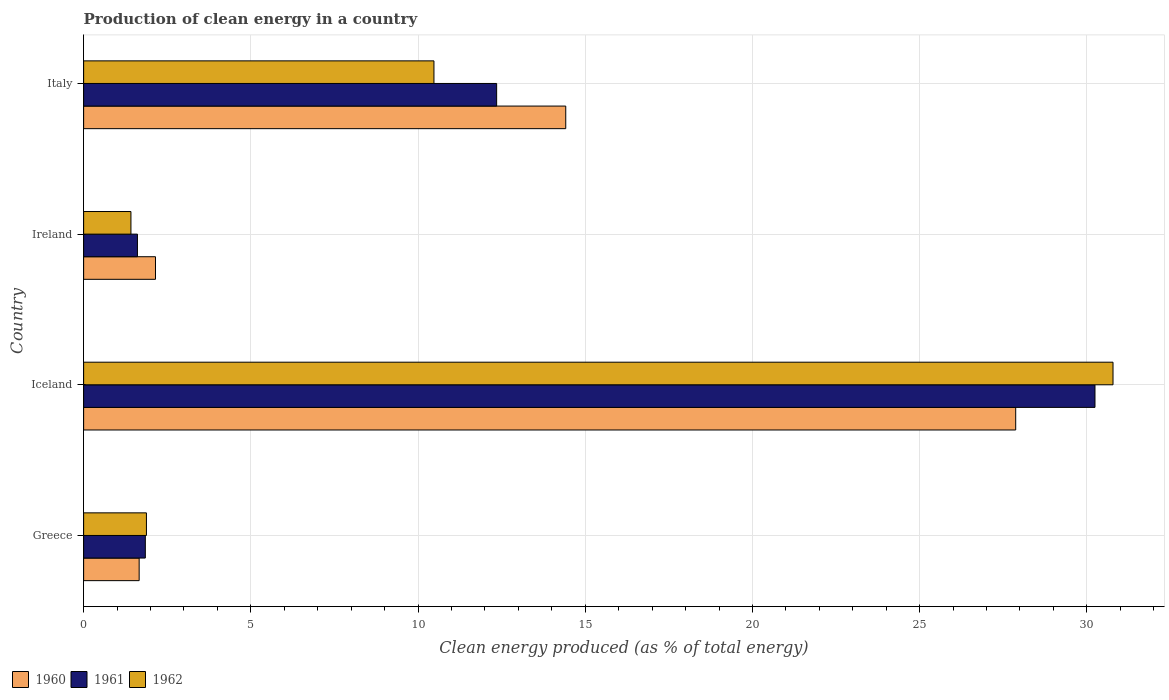How many different coloured bars are there?
Keep it short and to the point. 3. How many groups of bars are there?
Provide a succinct answer. 4. Are the number of bars on each tick of the Y-axis equal?
Ensure brevity in your answer.  Yes. How many bars are there on the 2nd tick from the top?
Offer a very short reply. 3. What is the label of the 1st group of bars from the top?
Your response must be concise. Italy. What is the percentage of clean energy produced in 1960 in Italy?
Keep it short and to the point. 14.42. Across all countries, what is the maximum percentage of clean energy produced in 1961?
Give a very brief answer. 30.24. Across all countries, what is the minimum percentage of clean energy produced in 1961?
Your answer should be compact. 1.61. In which country was the percentage of clean energy produced in 1960 maximum?
Keep it short and to the point. Iceland. In which country was the percentage of clean energy produced in 1962 minimum?
Your answer should be compact. Ireland. What is the total percentage of clean energy produced in 1960 in the graph?
Offer a very short reply. 46.1. What is the difference between the percentage of clean energy produced in 1960 in Greece and that in Italy?
Offer a very short reply. -12.76. What is the difference between the percentage of clean energy produced in 1962 in Italy and the percentage of clean energy produced in 1960 in Iceland?
Provide a succinct answer. -17.4. What is the average percentage of clean energy produced in 1960 per country?
Provide a succinct answer. 11.52. What is the difference between the percentage of clean energy produced in 1961 and percentage of clean energy produced in 1962 in Italy?
Provide a succinct answer. 1.87. What is the ratio of the percentage of clean energy produced in 1962 in Greece to that in Iceland?
Your response must be concise. 0.06. What is the difference between the highest and the second highest percentage of clean energy produced in 1962?
Provide a succinct answer. 20.31. What is the difference between the highest and the lowest percentage of clean energy produced in 1962?
Your response must be concise. 29.37. Is the sum of the percentage of clean energy produced in 1962 in Iceland and Italy greater than the maximum percentage of clean energy produced in 1960 across all countries?
Offer a terse response. Yes. What does the 3rd bar from the top in Greece represents?
Give a very brief answer. 1960. What does the 1st bar from the bottom in Iceland represents?
Make the answer very short. 1960. Is it the case that in every country, the sum of the percentage of clean energy produced in 1960 and percentage of clean energy produced in 1961 is greater than the percentage of clean energy produced in 1962?
Make the answer very short. Yes. How many bars are there?
Your answer should be compact. 12. What is the difference between two consecutive major ticks on the X-axis?
Make the answer very short. 5. Are the values on the major ticks of X-axis written in scientific E-notation?
Your answer should be compact. No. Does the graph contain any zero values?
Keep it short and to the point. No. How many legend labels are there?
Your answer should be very brief. 3. What is the title of the graph?
Provide a short and direct response. Production of clean energy in a country. What is the label or title of the X-axis?
Your response must be concise. Clean energy produced (as % of total energy). What is the label or title of the Y-axis?
Give a very brief answer. Country. What is the Clean energy produced (as % of total energy) of 1960 in Greece?
Ensure brevity in your answer.  1.66. What is the Clean energy produced (as % of total energy) in 1961 in Greece?
Keep it short and to the point. 1.84. What is the Clean energy produced (as % of total energy) of 1962 in Greece?
Keep it short and to the point. 1.88. What is the Clean energy produced (as % of total energy) in 1960 in Iceland?
Your response must be concise. 27.87. What is the Clean energy produced (as % of total energy) in 1961 in Iceland?
Offer a terse response. 30.24. What is the Clean energy produced (as % of total energy) in 1962 in Iceland?
Your answer should be compact. 30.78. What is the Clean energy produced (as % of total energy) in 1960 in Ireland?
Your answer should be compact. 2.15. What is the Clean energy produced (as % of total energy) of 1961 in Ireland?
Your response must be concise. 1.61. What is the Clean energy produced (as % of total energy) of 1962 in Ireland?
Give a very brief answer. 1.41. What is the Clean energy produced (as % of total energy) of 1960 in Italy?
Provide a short and direct response. 14.42. What is the Clean energy produced (as % of total energy) in 1961 in Italy?
Offer a very short reply. 12.35. What is the Clean energy produced (as % of total energy) of 1962 in Italy?
Ensure brevity in your answer.  10.48. Across all countries, what is the maximum Clean energy produced (as % of total energy) in 1960?
Your answer should be very brief. 27.87. Across all countries, what is the maximum Clean energy produced (as % of total energy) of 1961?
Make the answer very short. 30.24. Across all countries, what is the maximum Clean energy produced (as % of total energy) in 1962?
Provide a short and direct response. 30.78. Across all countries, what is the minimum Clean energy produced (as % of total energy) of 1960?
Your answer should be compact. 1.66. Across all countries, what is the minimum Clean energy produced (as % of total energy) of 1961?
Ensure brevity in your answer.  1.61. Across all countries, what is the minimum Clean energy produced (as % of total energy) of 1962?
Offer a terse response. 1.41. What is the total Clean energy produced (as % of total energy) of 1960 in the graph?
Ensure brevity in your answer.  46.1. What is the total Clean energy produced (as % of total energy) in 1961 in the graph?
Offer a very short reply. 46.05. What is the total Clean energy produced (as % of total energy) in 1962 in the graph?
Provide a short and direct response. 44.55. What is the difference between the Clean energy produced (as % of total energy) of 1960 in Greece and that in Iceland?
Keep it short and to the point. -26.21. What is the difference between the Clean energy produced (as % of total energy) in 1961 in Greece and that in Iceland?
Make the answer very short. -28.4. What is the difference between the Clean energy produced (as % of total energy) of 1962 in Greece and that in Iceland?
Make the answer very short. -28.9. What is the difference between the Clean energy produced (as % of total energy) in 1960 in Greece and that in Ireland?
Provide a succinct answer. -0.49. What is the difference between the Clean energy produced (as % of total energy) of 1961 in Greece and that in Ireland?
Offer a terse response. 0.24. What is the difference between the Clean energy produced (as % of total energy) of 1962 in Greece and that in Ireland?
Make the answer very short. 0.46. What is the difference between the Clean energy produced (as % of total energy) in 1960 in Greece and that in Italy?
Your answer should be very brief. -12.76. What is the difference between the Clean energy produced (as % of total energy) of 1961 in Greece and that in Italy?
Keep it short and to the point. -10.51. What is the difference between the Clean energy produced (as % of total energy) of 1962 in Greece and that in Italy?
Ensure brevity in your answer.  -8.6. What is the difference between the Clean energy produced (as % of total energy) of 1960 in Iceland and that in Ireland?
Your answer should be compact. 25.72. What is the difference between the Clean energy produced (as % of total energy) in 1961 in Iceland and that in Ireland?
Offer a very short reply. 28.63. What is the difference between the Clean energy produced (as % of total energy) of 1962 in Iceland and that in Ireland?
Offer a very short reply. 29.37. What is the difference between the Clean energy produced (as % of total energy) of 1960 in Iceland and that in Italy?
Offer a terse response. 13.46. What is the difference between the Clean energy produced (as % of total energy) of 1961 in Iceland and that in Italy?
Your answer should be very brief. 17.89. What is the difference between the Clean energy produced (as % of total energy) in 1962 in Iceland and that in Italy?
Ensure brevity in your answer.  20.31. What is the difference between the Clean energy produced (as % of total energy) in 1960 in Ireland and that in Italy?
Offer a terse response. -12.27. What is the difference between the Clean energy produced (as % of total energy) in 1961 in Ireland and that in Italy?
Ensure brevity in your answer.  -10.74. What is the difference between the Clean energy produced (as % of total energy) of 1962 in Ireland and that in Italy?
Give a very brief answer. -9.06. What is the difference between the Clean energy produced (as % of total energy) in 1960 in Greece and the Clean energy produced (as % of total energy) in 1961 in Iceland?
Ensure brevity in your answer.  -28.58. What is the difference between the Clean energy produced (as % of total energy) of 1960 in Greece and the Clean energy produced (as % of total energy) of 1962 in Iceland?
Ensure brevity in your answer.  -29.12. What is the difference between the Clean energy produced (as % of total energy) of 1961 in Greece and the Clean energy produced (as % of total energy) of 1962 in Iceland?
Ensure brevity in your answer.  -28.94. What is the difference between the Clean energy produced (as % of total energy) in 1960 in Greece and the Clean energy produced (as % of total energy) in 1961 in Ireland?
Ensure brevity in your answer.  0.05. What is the difference between the Clean energy produced (as % of total energy) in 1960 in Greece and the Clean energy produced (as % of total energy) in 1962 in Ireland?
Provide a short and direct response. 0.25. What is the difference between the Clean energy produced (as % of total energy) in 1961 in Greece and the Clean energy produced (as % of total energy) in 1962 in Ireland?
Provide a short and direct response. 0.43. What is the difference between the Clean energy produced (as % of total energy) of 1960 in Greece and the Clean energy produced (as % of total energy) of 1961 in Italy?
Offer a very short reply. -10.69. What is the difference between the Clean energy produced (as % of total energy) of 1960 in Greece and the Clean energy produced (as % of total energy) of 1962 in Italy?
Ensure brevity in your answer.  -8.82. What is the difference between the Clean energy produced (as % of total energy) in 1961 in Greece and the Clean energy produced (as % of total energy) in 1962 in Italy?
Your answer should be very brief. -8.63. What is the difference between the Clean energy produced (as % of total energy) of 1960 in Iceland and the Clean energy produced (as % of total energy) of 1961 in Ireland?
Keep it short and to the point. 26.26. What is the difference between the Clean energy produced (as % of total energy) in 1960 in Iceland and the Clean energy produced (as % of total energy) in 1962 in Ireland?
Provide a succinct answer. 26.46. What is the difference between the Clean energy produced (as % of total energy) of 1961 in Iceland and the Clean energy produced (as % of total energy) of 1962 in Ireland?
Make the answer very short. 28.83. What is the difference between the Clean energy produced (as % of total energy) in 1960 in Iceland and the Clean energy produced (as % of total energy) in 1961 in Italy?
Your answer should be very brief. 15.52. What is the difference between the Clean energy produced (as % of total energy) of 1960 in Iceland and the Clean energy produced (as % of total energy) of 1962 in Italy?
Your answer should be compact. 17.4. What is the difference between the Clean energy produced (as % of total energy) in 1961 in Iceland and the Clean energy produced (as % of total energy) in 1962 in Italy?
Make the answer very short. 19.77. What is the difference between the Clean energy produced (as % of total energy) in 1960 in Ireland and the Clean energy produced (as % of total energy) in 1961 in Italy?
Offer a terse response. -10.2. What is the difference between the Clean energy produced (as % of total energy) in 1960 in Ireland and the Clean energy produced (as % of total energy) in 1962 in Italy?
Make the answer very short. -8.33. What is the difference between the Clean energy produced (as % of total energy) of 1961 in Ireland and the Clean energy produced (as % of total energy) of 1962 in Italy?
Keep it short and to the point. -8.87. What is the average Clean energy produced (as % of total energy) in 1960 per country?
Give a very brief answer. 11.52. What is the average Clean energy produced (as % of total energy) in 1961 per country?
Offer a terse response. 11.51. What is the average Clean energy produced (as % of total energy) in 1962 per country?
Offer a terse response. 11.14. What is the difference between the Clean energy produced (as % of total energy) in 1960 and Clean energy produced (as % of total energy) in 1961 in Greece?
Ensure brevity in your answer.  -0.18. What is the difference between the Clean energy produced (as % of total energy) of 1960 and Clean energy produced (as % of total energy) of 1962 in Greece?
Provide a short and direct response. -0.22. What is the difference between the Clean energy produced (as % of total energy) of 1961 and Clean energy produced (as % of total energy) of 1962 in Greece?
Your response must be concise. -0.03. What is the difference between the Clean energy produced (as % of total energy) in 1960 and Clean energy produced (as % of total energy) in 1961 in Iceland?
Your answer should be compact. -2.37. What is the difference between the Clean energy produced (as % of total energy) of 1960 and Clean energy produced (as % of total energy) of 1962 in Iceland?
Your response must be concise. -2.91. What is the difference between the Clean energy produced (as % of total energy) of 1961 and Clean energy produced (as % of total energy) of 1962 in Iceland?
Offer a very short reply. -0.54. What is the difference between the Clean energy produced (as % of total energy) in 1960 and Clean energy produced (as % of total energy) in 1961 in Ireland?
Keep it short and to the point. 0.54. What is the difference between the Clean energy produced (as % of total energy) of 1960 and Clean energy produced (as % of total energy) of 1962 in Ireland?
Your answer should be very brief. 0.73. What is the difference between the Clean energy produced (as % of total energy) of 1961 and Clean energy produced (as % of total energy) of 1962 in Ireland?
Give a very brief answer. 0.19. What is the difference between the Clean energy produced (as % of total energy) of 1960 and Clean energy produced (as % of total energy) of 1961 in Italy?
Offer a terse response. 2.07. What is the difference between the Clean energy produced (as % of total energy) in 1960 and Clean energy produced (as % of total energy) in 1962 in Italy?
Offer a terse response. 3.94. What is the difference between the Clean energy produced (as % of total energy) of 1961 and Clean energy produced (as % of total energy) of 1962 in Italy?
Give a very brief answer. 1.87. What is the ratio of the Clean energy produced (as % of total energy) in 1960 in Greece to that in Iceland?
Your response must be concise. 0.06. What is the ratio of the Clean energy produced (as % of total energy) of 1961 in Greece to that in Iceland?
Your answer should be very brief. 0.06. What is the ratio of the Clean energy produced (as % of total energy) of 1962 in Greece to that in Iceland?
Offer a very short reply. 0.06. What is the ratio of the Clean energy produced (as % of total energy) in 1960 in Greece to that in Ireland?
Your answer should be very brief. 0.77. What is the ratio of the Clean energy produced (as % of total energy) in 1961 in Greece to that in Ireland?
Your response must be concise. 1.15. What is the ratio of the Clean energy produced (as % of total energy) in 1962 in Greece to that in Ireland?
Ensure brevity in your answer.  1.33. What is the ratio of the Clean energy produced (as % of total energy) of 1960 in Greece to that in Italy?
Offer a terse response. 0.12. What is the ratio of the Clean energy produced (as % of total energy) in 1961 in Greece to that in Italy?
Keep it short and to the point. 0.15. What is the ratio of the Clean energy produced (as % of total energy) of 1962 in Greece to that in Italy?
Your answer should be very brief. 0.18. What is the ratio of the Clean energy produced (as % of total energy) in 1960 in Iceland to that in Ireland?
Ensure brevity in your answer.  12.97. What is the ratio of the Clean energy produced (as % of total energy) of 1961 in Iceland to that in Ireland?
Your answer should be compact. 18.79. What is the ratio of the Clean energy produced (as % of total energy) in 1962 in Iceland to that in Ireland?
Your response must be concise. 21.76. What is the ratio of the Clean energy produced (as % of total energy) of 1960 in Iceland to that in Italy?
Give a very brief answer. 1.93. What is the ratio of the Clean energy produced (as % of total energy) of 1961 in Iceland to that in Italy?
Your answer should be compact. 2.45. What is the ratio of the Clean energy produced (as % of total energy) of 1962 in Iceland to that in Italy?
Keep it short and to the point. 2.94. What is the ratio of the Clean energy produced (as % of total energy) of 1960 in Ireland to that in Italy?
Provide a succinct answer. 0.15. What is the ratio of the Clean energy produced (as % of total energy) of 1961 in Ireland to that in Italy?
Provide a succinct answer. 0.13. What is the ratio of the Clean energy produced (as % of total energy) in 1962 in Ireland to that in Italy?
Ensure brevity in your answer.  0.14. What is the difference between the highest and the second highest Clean energy produced (as % of total energy) of 1960?
Provide a succinct answer. 13.46. What is the difference between the highest and the second highest Clean energy produced (as % of total energy) in 1961?
Offer a very short reply. 17.89. What is the difference between the highest and the second highest Clean energy produced (as % of total energy) in 1962?
Offer a very short reply. 20.31. What is the difference between the highest and the lowest Clean energy produced (as % of total energy) in 1960?
Your answer should be very brief. 26.21. What is the difference between the highest and the lowest Clean energy produced (as % of total energy) in 1961?
Offer a very short reply. 28.63. What is the difference between the highest and the lowest Clean energy produced (as % of total energy) in 1962?
Make the answer very short. 29.37. 